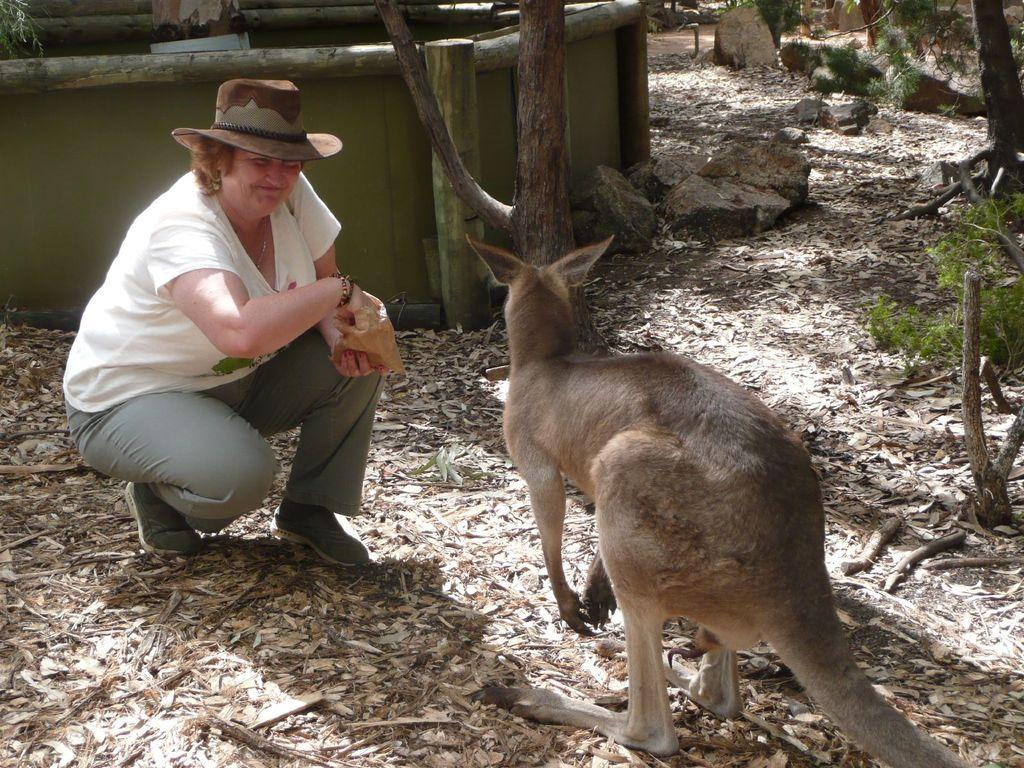What are the people in the image holding? The people in the image are holding something, but the facts do not specify what it is. What type of animal can be seen in the image? There is an animal in brown and white color in the image. What type of natural elements are present in the image? There are trees, rocks, and sticks in the image. What type of man-made structure is present in the image? There is a wall in the image. What type of scissors is the dad using in the image? There is no dad or scissors present in the image. What type of discussion is happening between the people in the image? The facts do not mention any discussion or conversation between the people in the image. 